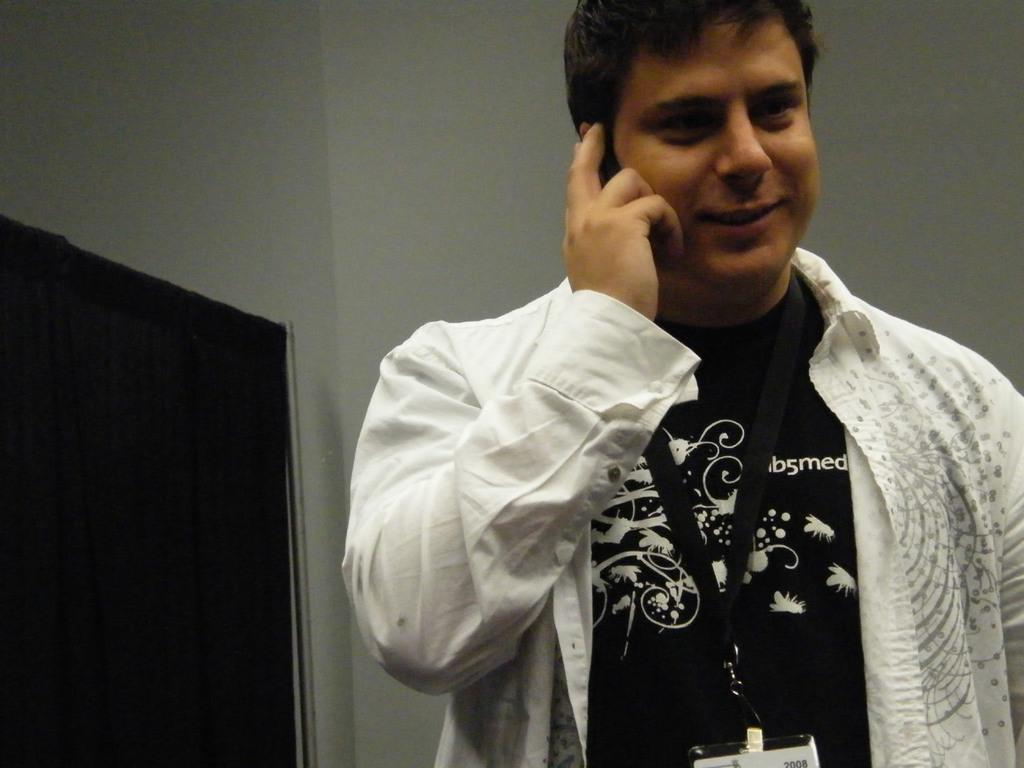What is the main subject in the foreground of the image? There is a man in the foreground of the image. What is the man wearing in the image? The man is wearing a black and white dress. How many corks are visible in the image? There are no corks present in the image. What type of carriage is the man using to travel in the image? There is no carriage present in the image; the man is standing in the foreground. 